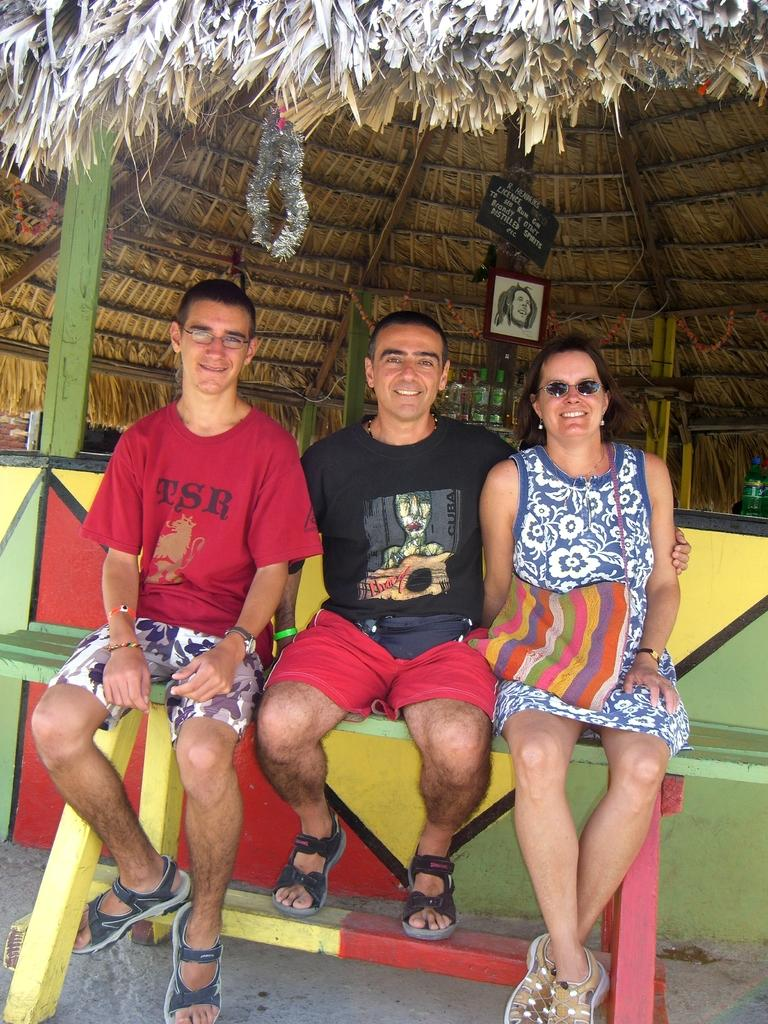How many people are in the image? There are two men and a woman in the image, making a total of three individuals. What are the people in the image doing? The individuals are sitting on a bench and smiling. What can be seen in the background of the image? There is a frame, bottles, and a hut in the background of the image. What type of straw is the woman using to drink from the bottle in the image? There is no straw visible in the image, and the woman is not shown drinking from a bottle. What does the dad of the woman in the image look like? There is no information about the woman's dad in the image, so we cannot describe his appearance. 